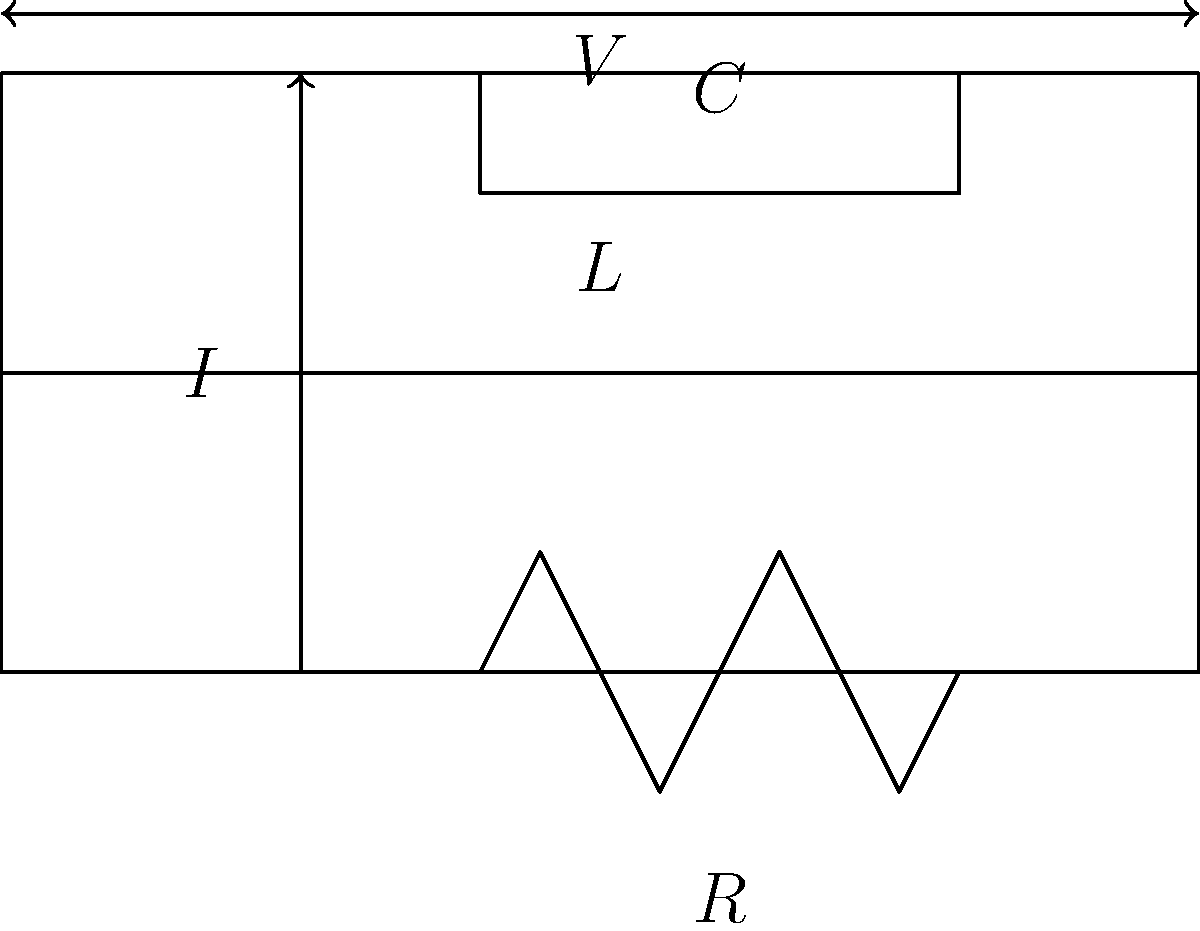As an illustrator seeking to understand circuit diagrams, analyze the given RLC circuit. If the applied voltage $V$ is sinusoidal with angular frequency $\omega$, derive an expression for the circuit's impedance $Z$. How does the impedance change as the frequency increases? To derive the expression for the circuit's impedance and understand how it changes with frequency, let's follow these steps:

1. Identify the components:
   - Resistor (R)
   - Inductor (L)
   - Capacitor (C)

2. Recall the impedance formulas for each component:
   - Resistor: $Z_R = R$
   - Inductor: $Z_L = j\omega L$
   - Capacitor: $Z_C = \frac{1}{j\omega C}$

3. Observe that the components are in series, so we add their impedances:
   $Z_{total} = Z_R + Z_L + Z_C$

4. Substitute the component impedances:
   $Z_{total} = R + j\omega L + \frac{1}{j\omega C}$

5. Simplify by finding a common denominator:
   $Z_{total} = R + j\omega L + \frac{1}{j\omega C} = R + j\omega L - \frac{j}{\omega C}$

6. Combine like terms:
   $Z_{total} = R + j(\omega L - \frac{1}{\omega C})$

7. Analyze the behavior as frequency (ω) increases:
   - The resistive part (R) remains constant
   - The inductive reactance (ωL) increases linearly
   - The capacitive reactance (1/ωC) decreases inversely

8. At low frequencies:
   - Inductive reactance is small
   - Capacitive reactance is large
   - Circuit behaves more like an RC circuit

9. At high frequencies:
   - Inductive reactance is large
   - Capacitive reactance is small
   - Circuit behaves more like an RL circuit

10. At a specific frequency where $\omega L = \frac{1}{\omega C}$:
    - Inductive and capacitive reactances cancel out
    - This is called the resonant frequency
    - Impedance is purely resistive (Z = R)
Answer: $Z = R + j(\omega L - \frac{1}{\omega C})$; As frequency increases, inductive reactance increases, capacitive reactance decreases. 